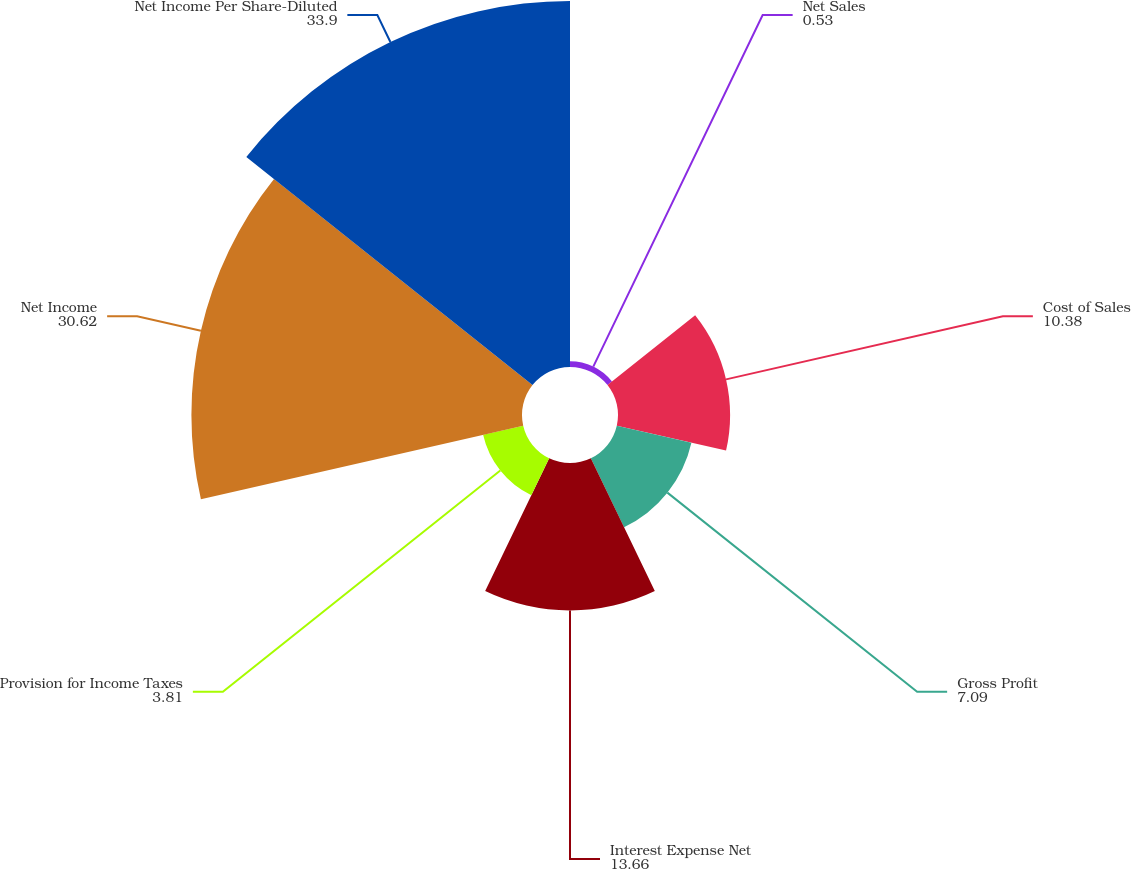<chart> <loc_0><loc_0><loc_500><loc_500><pie_chart><fcel>Net Sales<fcel>Cost of Sales<fcel>Gross Profit<fcel>Interest Expense Net<fcel>Provision for Income Taxes<fcel>Net Income<fcel>Net Income Per Share-Diluted<nl><fcel>0.53%<fcel>10.38%<fcel>7.09%<fcel>13.66%<fcel>3.81%<fcel>30.62%<fcel>33.9%<nl></chart> 